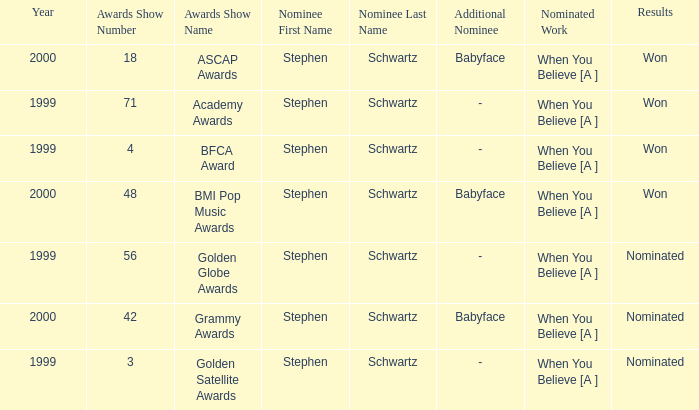What were the outcomes of the 71st academy awards ceremony? Won. 